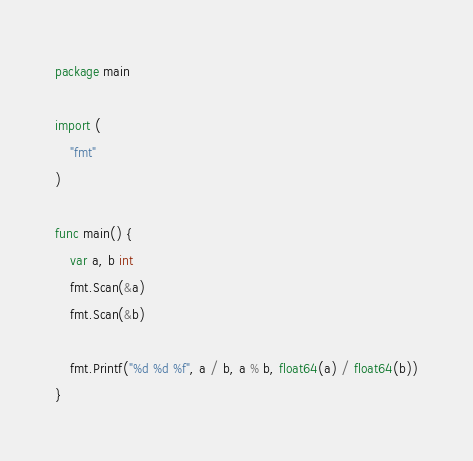Convert code to text. <code><loc_0><loc_0><loc_500><loc_500><_Go_>package main

import (
	"fmt"
)

func main() {
	var a, b int
	fmt.Scan(&a)
	fmt.Scan(&b)

	fmt.Printf("%d %d %f", a / b, a % b, float64(a) / float64(b))
}</code> 